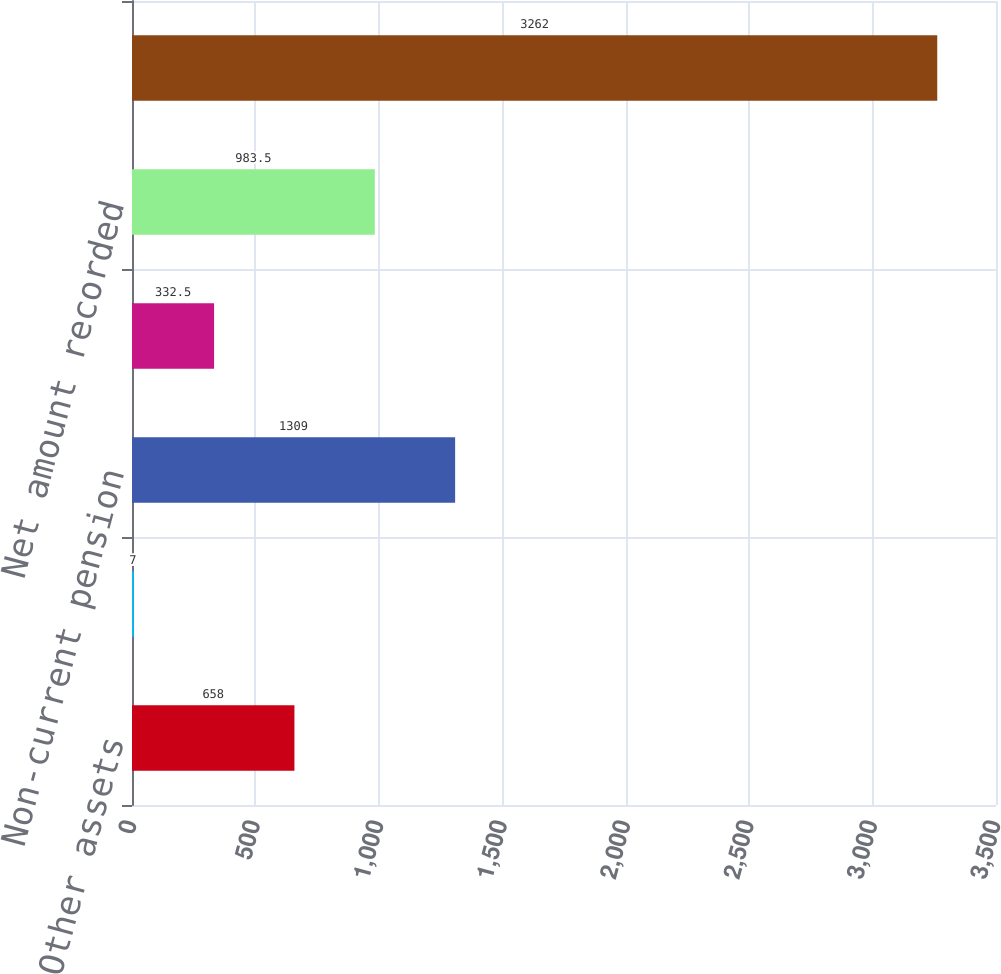Convert chart to OTSL. <chart><loc_0><loc_0><loc_500><loc_500><bar_chart><fcel>Other assets<fcel>Accrued expenses and other<fcel>Non-current pension<fcel>Other long-term liabilities -<fcel>Net amount recorded<fcel>Accumulated benefit obligation<nl><fcel>658<fcel>7<fcel>1309<fcel>332.5<fcel>983.5<fcel>3262<nl></chart> 